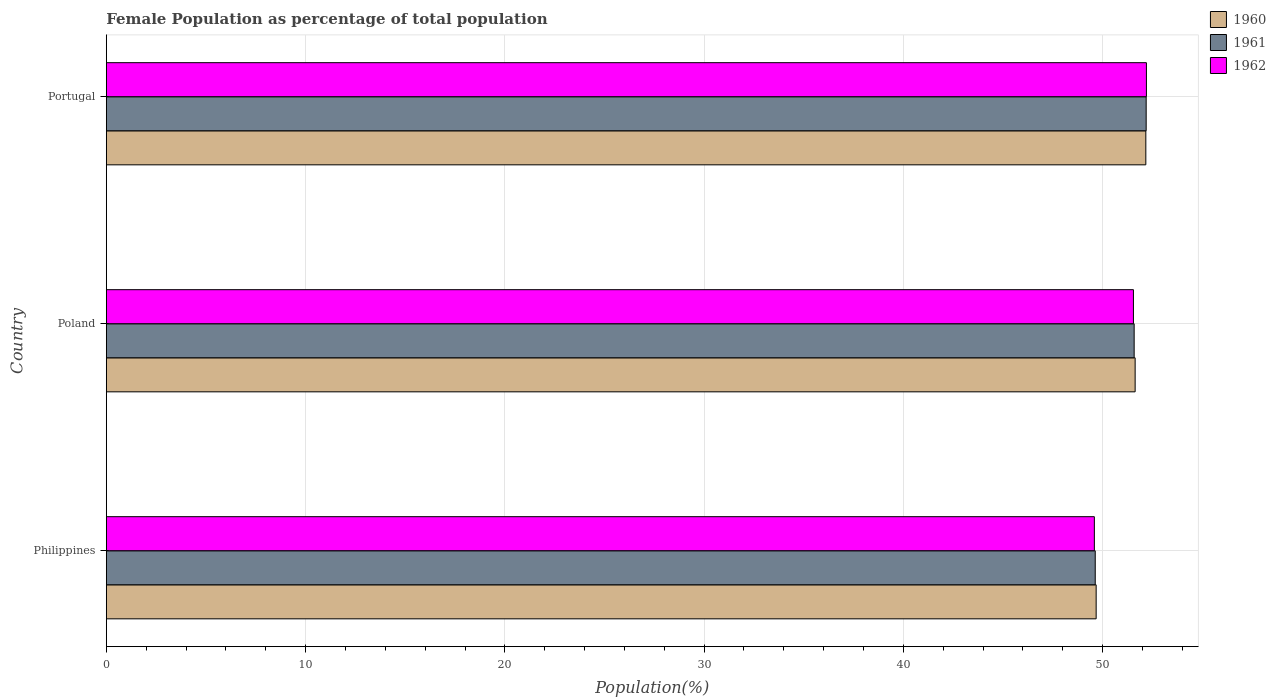How many different coloured bars are there?
Give a very brief answer. 3. How many groups of bars are there?
Provide a succinct answer. 3. How many bars are there on the 1st tick from the bottom?
Your response must be concise. 3. What is the female population in in 1961 in Poland?
Ensure brevity in your answer.  51.58. Across all countries, what is the maximum female population in in 1960?
Provide a short and direct response. 52.17. Across all countries, what is the minimum female population in in 1961?
Your answer should be very brief. 49.63. In which country was the female population in in 1960 maximum?
Ensure brevity in your answer.  Portugal. In which country was the female population in in 1960 minimum?
Offer a very short reply. Philippines. What is the total female population in in 1961 in the graph?
Ensure brevity in your answer.  153.4. What is the difference between the female population in in 1962 in Philippines and that in Portugal?
Give a very brief answer. -2.61. What is the difference between the female population in in 1962 in Poland and the female population in in 1960 in Philippines?
Ensure brevity in your answer.  1.87. What is the average female population in in 1962 per country?
Provide a short and direct response. 51.11. What is the difference between the female population in in 1962 and female population in in 1961 in Poland?
Ensure brevity in your answer.  -0.04. In how many countries, is the female population in in 1961 greater than 18 %?
Give a very brief answer. 3. What is the ratio of the female population in in 1960 in Philippines to that in Portugal?
Keep it short and to the point. 0.95. Is the female population in in 1961 in Poland less than that in Portugal?
Keep it short and to the point. Yes. What is the difference between the highest and the second highest female population in in 1962?
Give a very brief answer. 0.65. What is the difference between the highest and the lowest female population in in 1962?
Make the answer very short. 2.61. What does the 1st bar from the top in Philippines represents?
Ensure brevity in your answer.  1962. Are all the bars in the graph horizontal?
Give a very brief answer. Yes. Does the graph contain any zero values?
Your answer should be compact. No. Does the graph contain grids?
Provide a succinct answer. Yes. How many legend labels are there?
Make the answer very short. 3. How are the legend labels stacked?
Your response must be concise. Vertical. What is the title of the graph?
Give a very brief answer. Female Population as percentage of total population. Does "1984" appear as one of the legend labels in the graph?
Offer a very short reply. No. What is the label or title of the X-axis?
Provide a succinct answer. Population(%). What is the Population(%) of 1960 in Philippines?
Give a very brief answer. 49.67. What is the Population(%) in 1961 in Philippines?
Provide a short and direct response. 49.63. What is the Population(%) in 1962 in Philippines?
Offer a very short reply. 49.58. What is the Population(%) in 1960 in Poland?
Your response must be concise. 51.63. What is the Population(%) of 1961 in Poland?
Your response must be concise. 51.58. What is the Population(%) in 1962 in Poland?
Provide a short and direct response. 51.55. What is the Population(%) in 1960 in Portugal?
Your answer should be very brief. 52.17. What is the Population(%) of 1961 in Portugal?
Give a very brief answer. 52.19. What is the Population(%) of 1962 in Portugal?
Make the answer very short. 52.2. Across all countries, what is the maximum Population(%) in 1960?
Your answer should be very brief. 52.17. Across all countries, what is the maximum Population(%) of 1961?
Provide a succinct answer. 52.19. Across all countries, what is the maximum Population(%) of 1962?
Your response must be concise. 52.2. Across all countries, what is the minimum Population(%) in 1960?
Give a very brief answer. 49.67. Across all countries, what is the minimum Population(%) in 1961?
Make the answer very short. 49.63. Across all countries, what is the minimum Population(%) of 1962?
Offer a terse response. 49.58. What is the total Population(%) of 1960 in the graph?
Offer a terse response. 153.47. What is the total Population(%) of 1961 in the graph?
Offer a terse response. 153.4. What is the total Population(%) of 1962 in the graph?
Offer a very short reply. 153.33. What is the difference between the Population(%) in 1960 in Philippines and that in Poland?
Offer a terse response. -1.96. What is the difference between the Population(%) of 1961 in Philippines and that in Poland?
Your response must be concise. -1.95. What is the difference between the Population(%) of 1962 in Philippines and that in Poland?
Ensure brevity in your answer.  -1.96. What is the difference between the Population(%) of 1960 in Philippines and that in Portugal?
Give a very brief answer. -2.49. What is the difference between the Population(%) in 1961 in Philippines and that in Portugal?
Your response must be concise. -2.56. What is the difference between the Population(%) in 1962 in Philippines and that in Portugal?
Your answer should be very brief. -2.61. What is the difference between the Population(%) in 1960 in Poland and that in Portugal?
Ensure brevity in your answer.  -0.54. What is the difference between the Population(%) in 1961 in Poland and that in Portugal?
Provide a short and direct response. -0.6. What is the difference between the Population(%) of 1962 in Poland and that in Portugal?
Your response must be concise. -0.65. What is the difference between the Population(%) of 1960 in Philippines and the Population(%) of 1961 in Poland?
Your response must be concise. -1.91. What is the difference between the Population(%) in 1960 in Philippines and the Population(%) in 1962 in Poland?
Give a very brief answer. -1.87. What is the difference between the Population(%) of 1961 in Philippines and the Population(%) of 1962 in Poland?
Provide a short and direct response. -1.92. What is the difference between the Population(%) of 1960 in Philippines and the Population(%) of 1961 in Portugal?
Ensure brevity in your answer.  -2.51. What is the difference between the Population(%) in 1960 in Philippines and the Population(%) in 1962 in Portugal?
Provide a succinct answer. -2.52. What is the difference between the Population(%) of 1961 in Philippines and the Population(%) of 1962 in Portugal?
Provide a succinct answer. -2.57. What is the difference between the Population(%) in 1960 in Poland and the Population(%) in 1961 in Portugal?
Ensure brevity in your answer.  -0.55. What is the difference between the Population(%) of 1960 in Poland and the Population(%) of 1962 in Portugal?
Offer a very short reply. -0.57. What is the difference between the Population(%) of 1961 in Poland and the Population(%) of 1962 in Portugal?
Keep it short and to the point. -0.62. What is the average Population(%) of 1960 per country?
Provide a succinct answer. 51.16. What is the average Population(%) in 1961 per country?
Your answer should be very brief. 51.13. What is the average Population(%) of 1962 per country?
Your answer should be compact. 51.11. What is the difference between the Population(%) of 1960 and Population(%) of 1961 in Philippines?
Offer a very short reply. 0.05. What is the difference between the Population(%) of 1960 and Population(%) of 1962 in Philippines?
Your response must be concise. 0.09. What is the difference between the Population(%) of 1961 and Population(%) of 1962 in Philippines?
Provide a succinct answer. 0.04. What is the difference between the Population(%) in 1960 and Population(%) in 1961 in Poland?
Give a very brief answer. 0.05. What is the difference between the Population(%) of 1960 and Population(%) of 1962 in Poland?
Keep it short and to the point. 0.09. What is the difference between the Population(%) in 1961 and Population(%) in 1962 in Poland?
Keep it short and to the point. 0.04. What is the difference between the Population(%) in 1960 and Population(%) in 1961 in Portugal?
Make the answer very short. -0.02. What is the difference between the Population(%) in 1960 and Population(%) in 1962 in Portugal?
Your answer should be compact. -0.03. What is the difference between the Population(%) of 1961 and Population(%) of 1962 in Portugal?
Make the answer very short. -0.01. What is the ratio of the Population(%) in 1960 in Philippines to that in Poland?
Provide a succinct answer. 0.96. What is the ratio of the Population(%) of 1961 in Philippines to that in Poland?
Your answer should be very brief. 0.96. What is the ratio of the Population(%) of 1962 in Philippines to that in Poland?
Offer a terse response. 0.96. What is the ratio of the Population(%) of 1960 in Philippines to that in Portugal?
Keep it short and to the point. 0.95. What is the ratio of the Population(%) in 1961 in Philippines to that in Portugal?
Provide a short and direct response. 0.95. What is the ratio of the Population(%) of 1962 in Philippines to that in Portugal?
Offer a very short reply. 0.95. What is the ratio of the Population(%) of 1960 in Poland to that in Portugal?
Provide a succinct answer. 0.99. What is the ratio of the Population(%) of 1961 in Poland to that in Portugal?
Offer a very short reply. 0.99. What is the ratio of the Population(%) of 1962 in Poland to that in Portugal?
Provide a short and direct response. 0.99. What is the difference between the highest and the second highest Population(%) in 1960?
Keep it short and to the point. 0.54. What is the difference between the highest and the second highest Population(%) of 1961?
Ensure brevity in your answer.  0.6. What is the difference between the highest and the second highest Population(%) of 1962?
Offer a very short reply. 0.65. What is the difference between the highest and the lowest Population(%) of 1960?
Make the answer very short. 2.49. What is the difference between the highest and the lowest Population(%) in 1961?
Offer a very short reply. 2.56. What is the difference between the highest and the lowest Population(%) of 1962?
Make the answer very short. 2.61. 